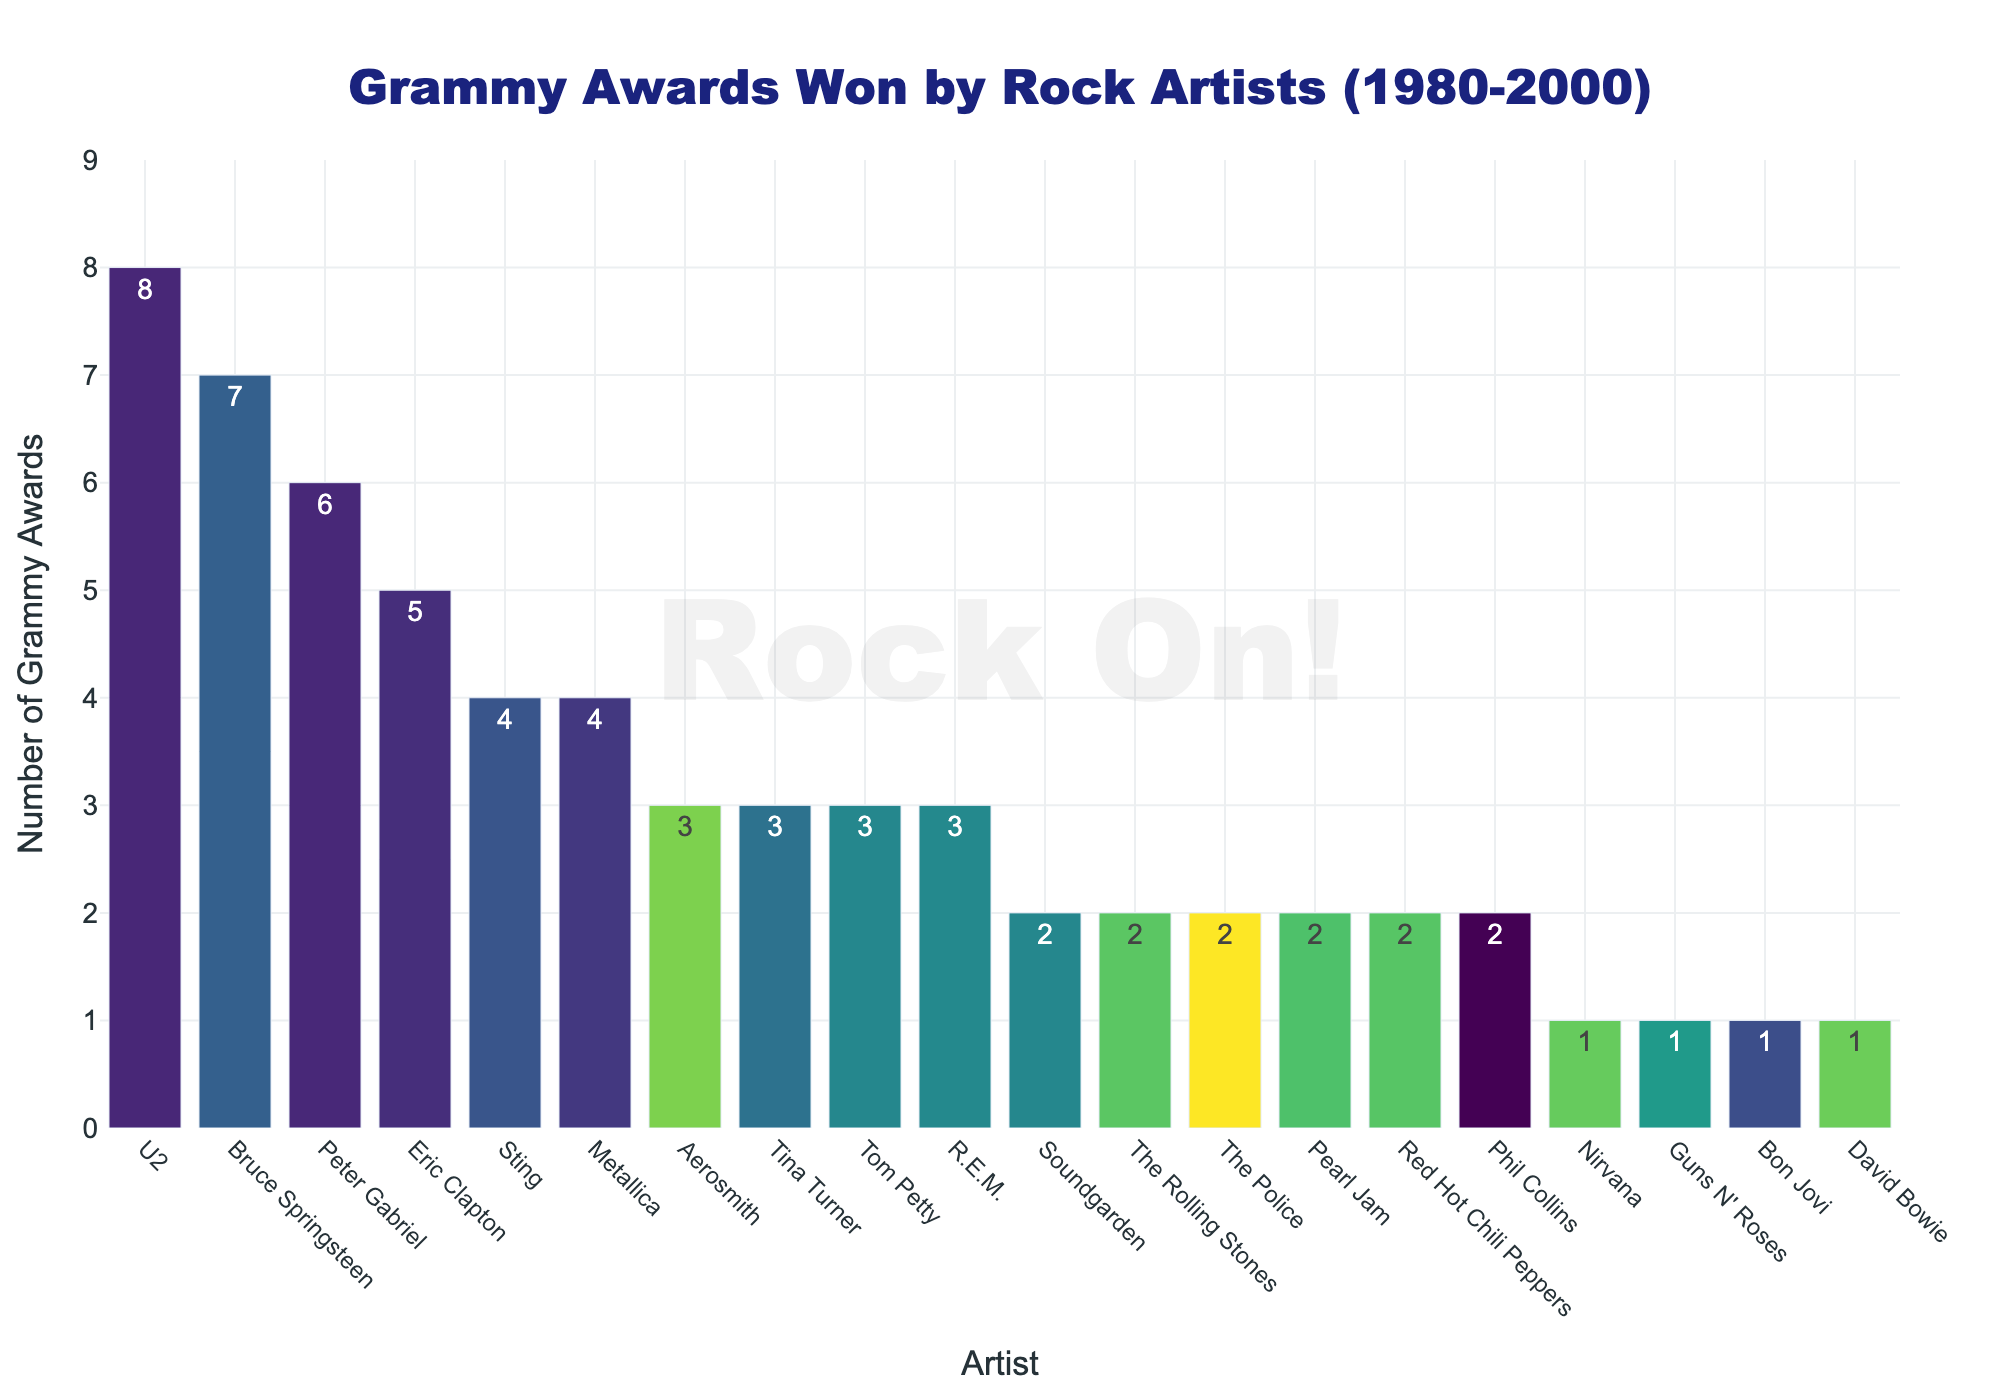Which artist won the most Grammy Awards in the rock genre between 1980 to 2000? To determine the artist with the most Grammy Awards, look at who has the tallest bar in the chart. U2 has the tallest bar with 8 Grammy Awards.
Answer: U2 How many more Grammy Awards did Bruce Springsteen win compared to Eric Clapton? First, find Bruce Springsteen's Grammy Awards (7) and Eric Clapton's Grammy Awards (5). Subtract 5 from 7 to get the difference.
Answer: 2 Which artists tied in the number of Grammy Awards won with 4 each? Identify the bars with a height representing 4 awards. Sting and Metallica both have bars with a height of 4.
Answer: Sting and Metallica What is the total number of Grammy Awards won by the top three artists? Add the number of awards of the top three artists: U2 (8) + Bruce Springsteen (7) + Peter Gabriel (6).
Answer: 21 How many artists won only 1 Grammy Award? Identify the bars that represent 1 Grammy Award. There are four such bars: Bon Jovi, Nirvana, Guns N' Roses, and David Bowie.
Answer: 4 Which artist won more Grammy Awards: Phil Collins or Red Hot Chili Peppers? Locate each artist's bar and compare their heights. Phil Collins has 2 Grammy Awards, and Red Hot Chili Peppers also have 2, so neither won more.
Answer: Neither What is the average number of Grammy Awards won by artists who received 2 awards? Find the total number of Grammy Awards for artists who received 2 awards: Red Hot Chili Peppers + The Police + Pearl Jam + Soundgarden + The Rolling Stones + Phil Collins (2+2+2+2+2+2). Divide by the number of such artists (6). Calculate 12 awards/6 artists.
Answer: 2 Who won more Grammy Awards: Aerosmith or Tom Petty? Compare the height of Aerosmith’s bar (3) with Tom Petty’s bar (3). They won the same number of awards.
Answer: Same What is the combined total of Grammy Awards won by Peter Gabriel and Tina Turner? Add Peter Gabriel's Grammy Awards (6) to Tina Turner's (3).
Answer: 9 Which artist's bar is closest in height to Eric Clapton's bar? Note that Eric Clapton's bar represents 5 Grammy Awards. The closest in height are Sting and Metallica, each with 4 awards, but none exactly match.
Answer: Sting and Metallica 